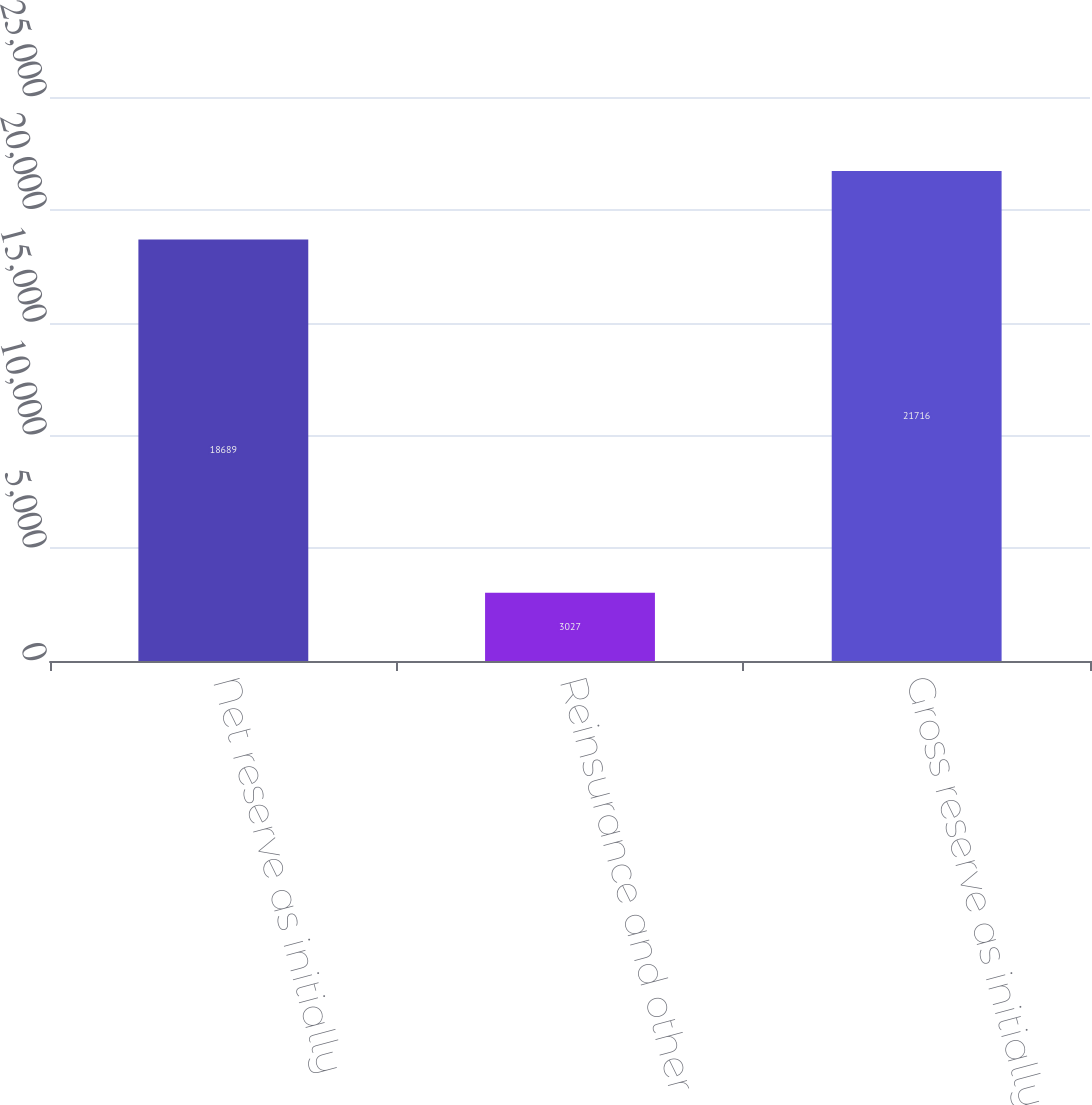<chart> <loc_0><loc_0><loc_500><loc_500><bar_chart><fcel>Net reserve as initially<fcel>Reinsurance and other<fcel>Gross reserve as initially<nl><fcel>18689<fcel>3027<fcel>21716<nl></chart> 